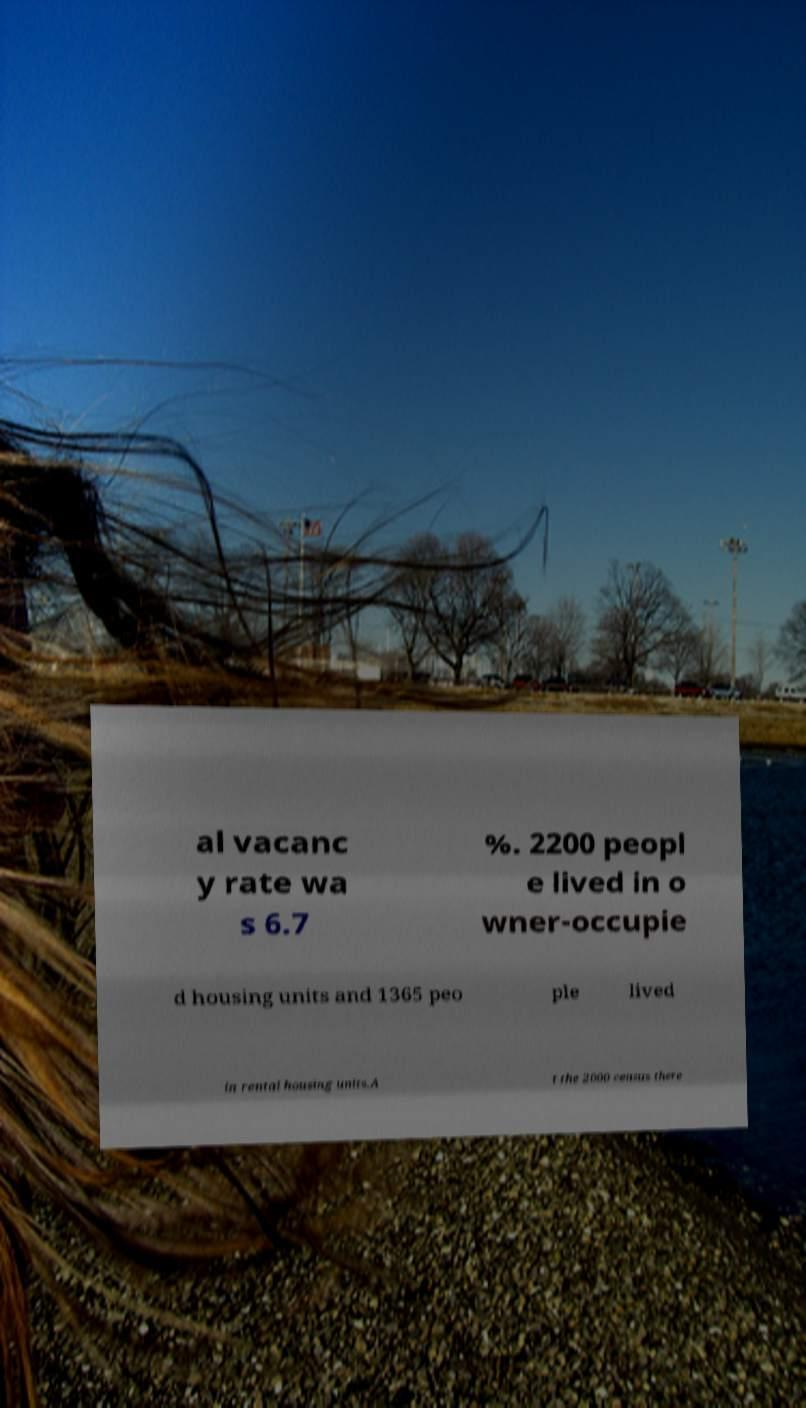Could you assist in decoding the text presented in this image and type it out clearly? al vacanc y rate wa s 6.7 %. 2200 peopl e lived in o wner-occupie d housing units and 1365 peo ple lived in rental housing units.A t the 2000 census there 